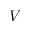Convert formula to latex. <formula><loc_0><loc_0><loc_500><loc_500>V</formula> 